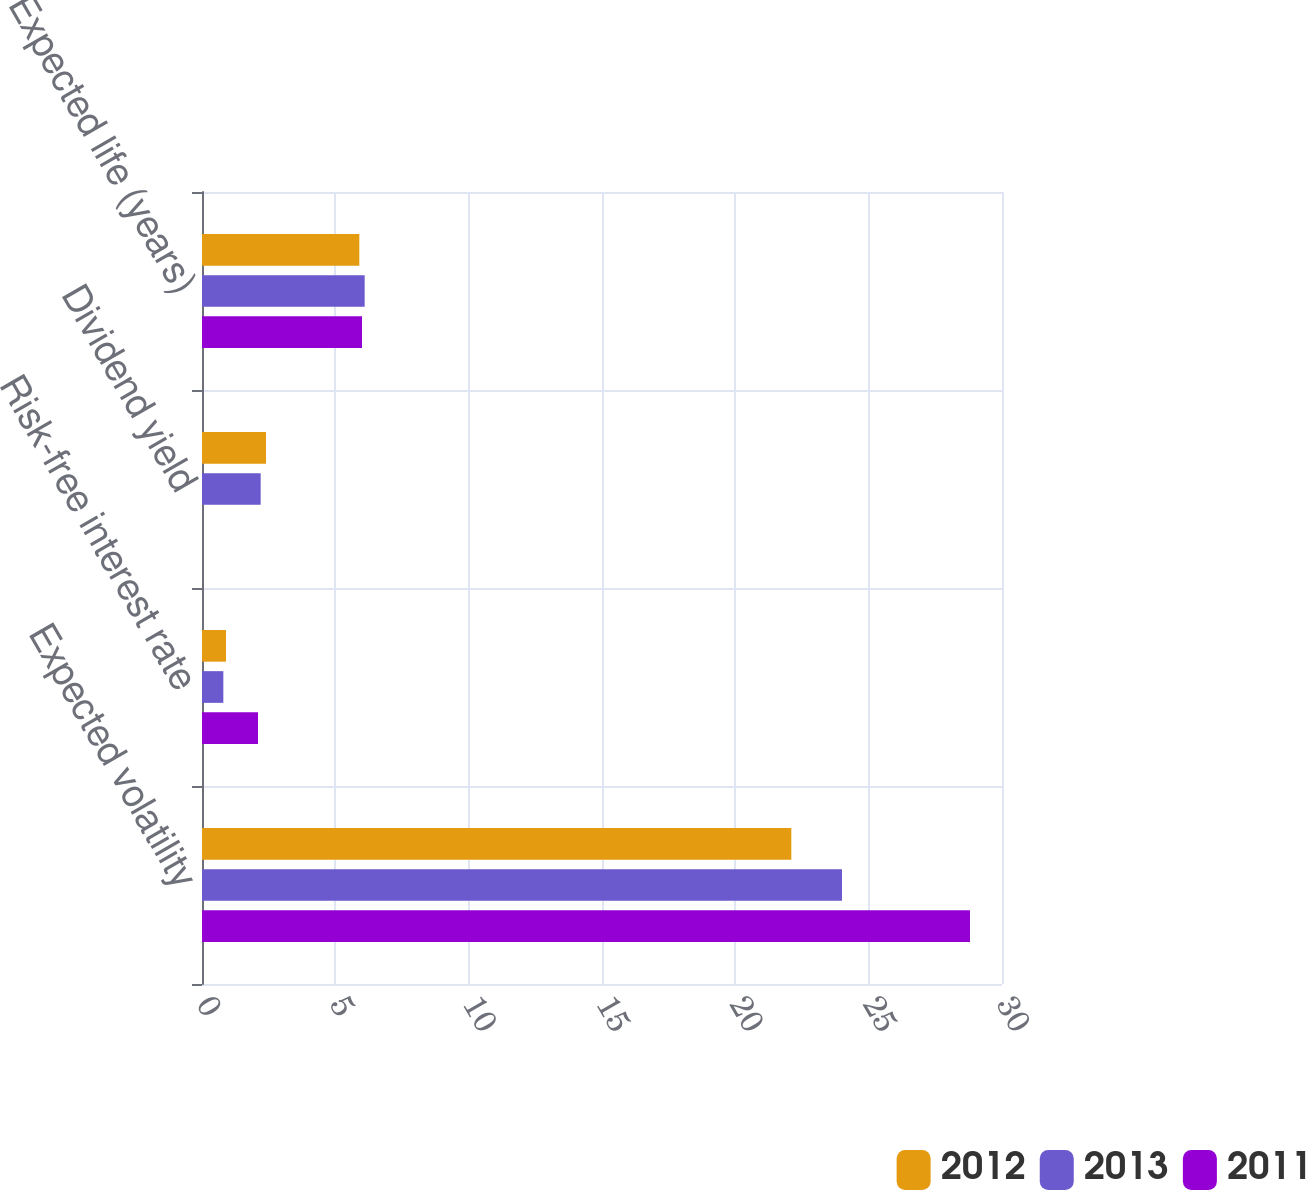Convert chart to OTSL. <chart><loc_0><loc_0><loc_500><loc_500><stacked_bar_chart><ecel><fcel>Expected volatility<fcel>Risk-free interest rate<fcel>Dividend yield<fcel>Expected life (years)<nl><fcel>2012<fcel>22.1<fcel>0.9<fcel>2.4<fcel>5.9<nl><fcel>2013<fcel>24<fcel>0.8<fcel>2.2<fcel>6.1<nl><fcel>2011<fcel>28.8<fcel>2.1<fcel>0<fcel>6<nl></chart> 